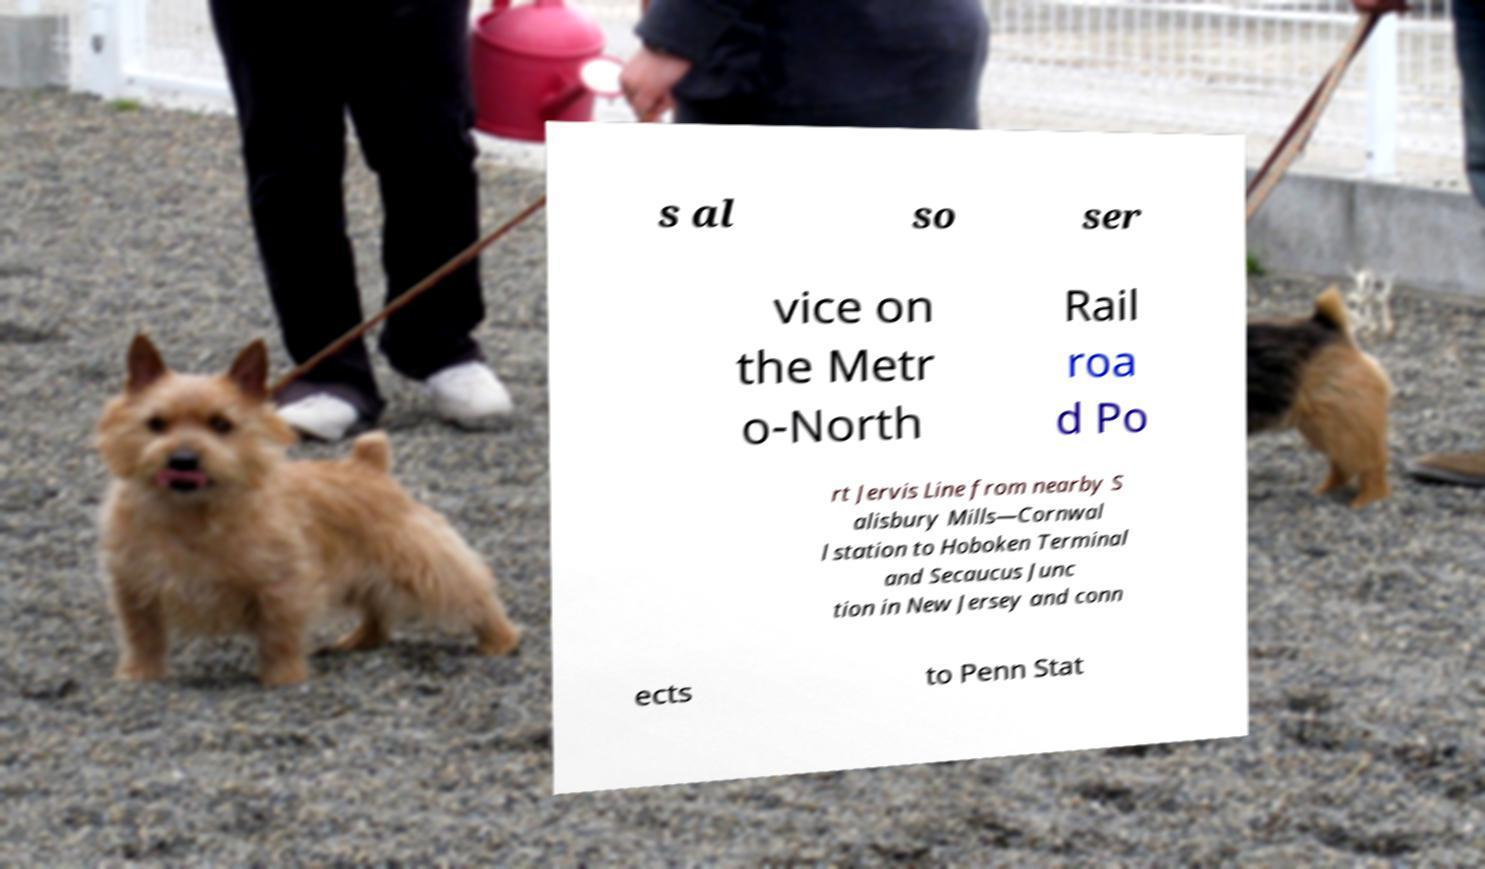Can you accurately transcribe the text from the provided image for me? s al so ser vice on the Metr o-North Rail roa d Po rt Jervis Line from nearby S alisbury Mills—Cornwal l station to Hoboken Terminal and Secaucus Junc tion in New Jersey and conn ects to Penn Stat 